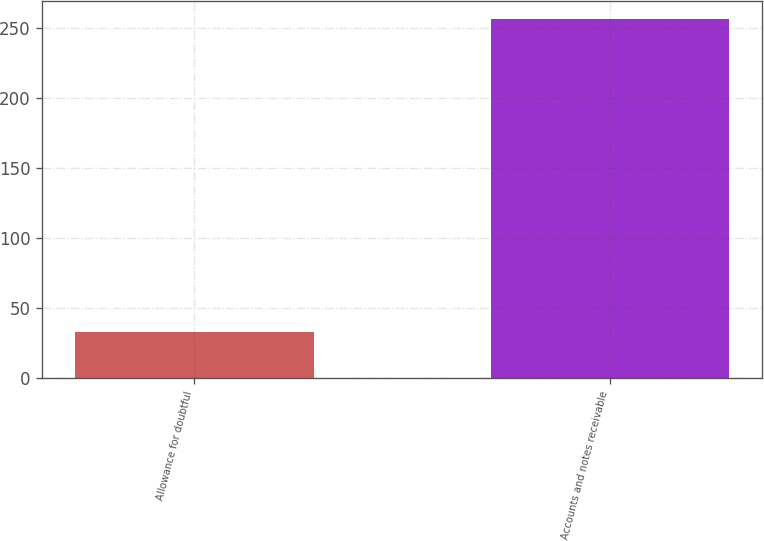<chart> <loc_0><loc_0><loc_500><loc_500><bar_chart><fcel>Allowance for doubtful<fcel>Accounts and notes receivable<nl><fcel>33<fcel>256<nl></chart> 